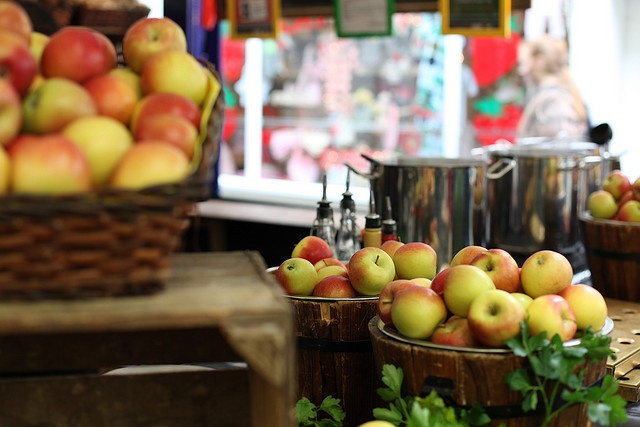Describe the objects in this image and their specific colors. I can see bowl in brown, black, darkgreen, and maroon tones, apple in brown, khaki, olive, and tan tones, apple in brown, red, orange, and maroon tones, bowl in brown, black, maroon, and olive tones, and apple in brown, olive, maroon, and khaki tones in this image. 